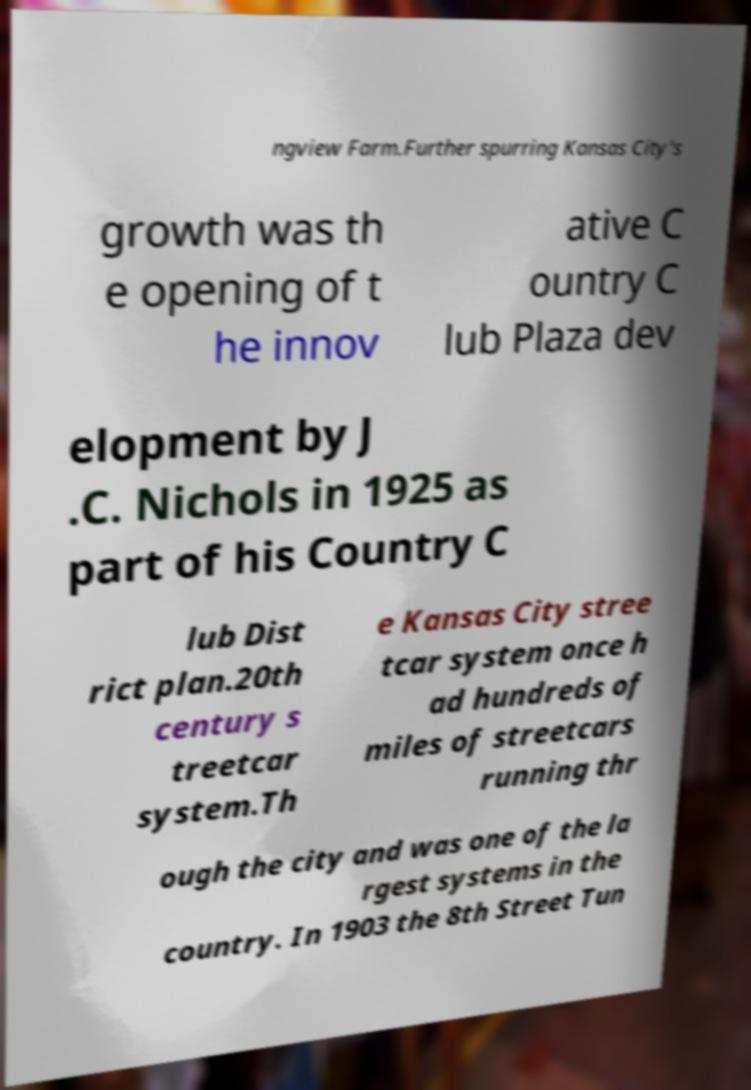Please read and relay the text visible in this image. What does it say? ngview Farm.Further spurring Kansas City's growth was th e opening of t he innov ative C ountry C lub Plaza dev elopment by J .C. Nichols in 1925 as part of his Country C lub Dist rict plan.20th century s treetcar system.Th e Kansas City stree tcar system once h ad hundreds of miles of streetcars running thr ough the city and was one of the la rgest systems in the country. In 1903 the 8th Street Tun 